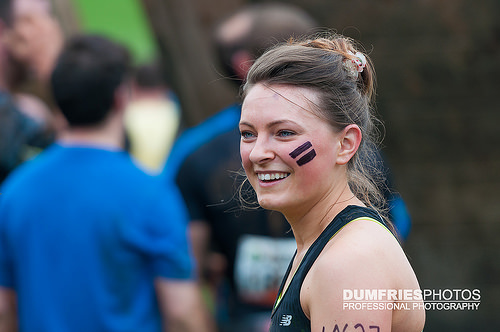<image>
Is there a man behind the lady? Yes. From this viewpoint, the man is positioned behind the lady, with the lady partially or fully occluding the man. 